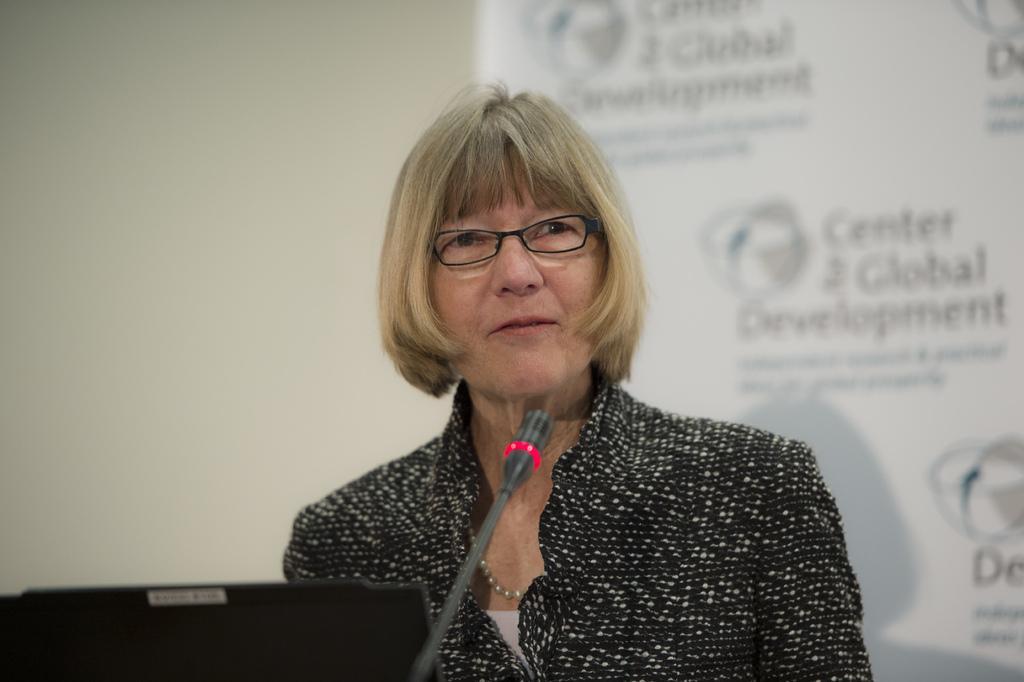Please provide a concise description of this image. The picture consists of a woman in black dress. In front of her there is a mic and laptop. The background is blurred. In the background there is a banner and a wall painted in white. 